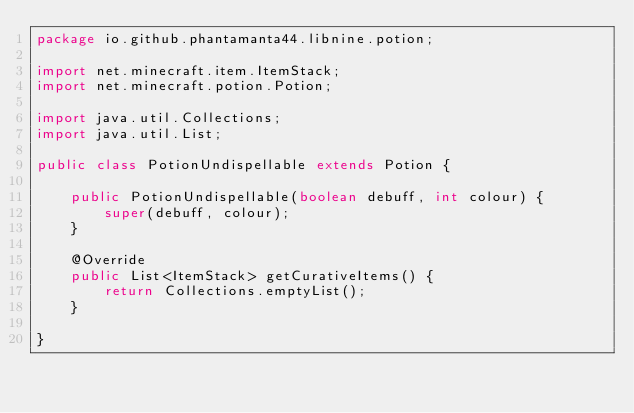<code> <loc_0><loc_0><loc_500><loc_500><_Java_>package io.github.phantamanta44.libnine.potion;

import net.minecraft.item.ItemStack;
import net.minecraft.potion.Potion;

import java.util.Collections;
import java.util.List;

public class PotionUndispellable extends Potion {

    public PotionUndispellable(boolean debuff, int colour) {
        super(debuff, colour);
    }

    @Override
    public List<ItemStack> getCurativeItems() {
        return Collections.emptyList();
    }

}
</code> 